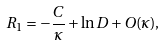<formula> <loc_0><loc_0><loc_500><loc_500>R _ { 1 } = - \frac { C } { \kappa } + \ln D + O ( \kappa ) ,</formula> 